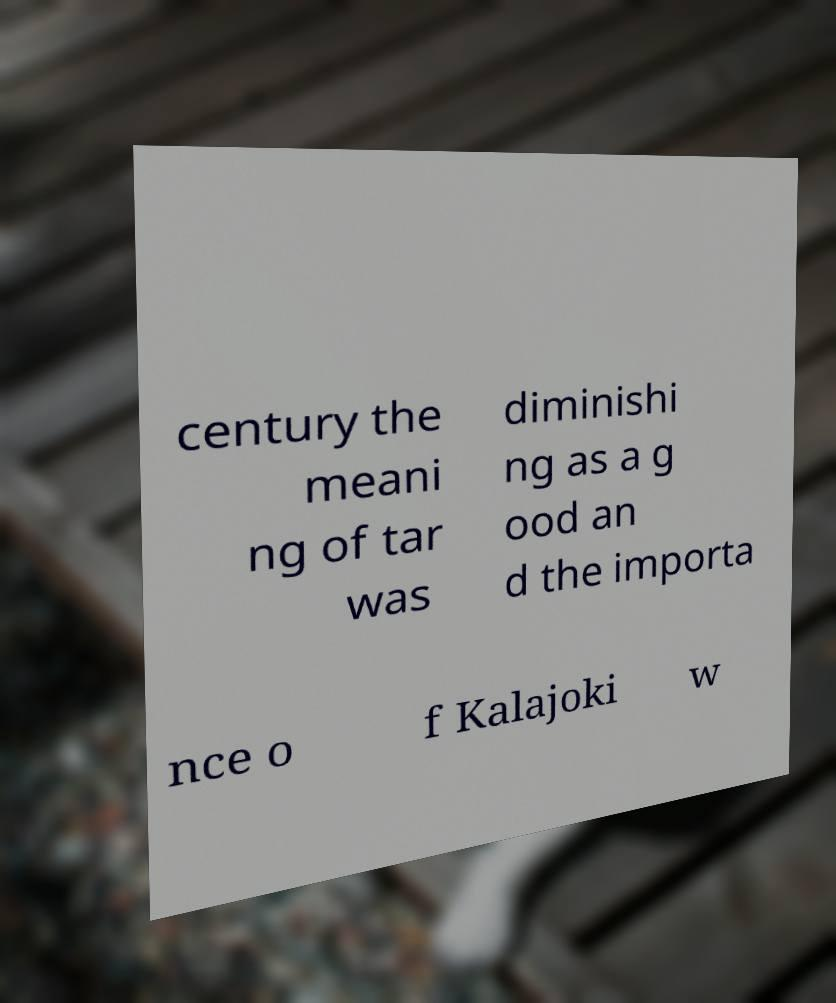Could you assist in decoding the text presented in this image and type it out clearly? century the meani ng of tar was diminishi ng as a g ood an d the importa nce o f Kalajoki w 